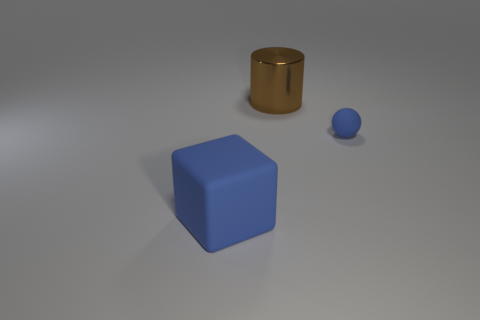Is there any other thing that is the same size as the matte sphere?
Give a very brief answer. No. There is a object that is in front of the small ball; is it the same color as the tiny thing?
Your answer should be very brief. Yes. What is the size of the blue matte object that is on the right side of the big thing that is behind the small blue rubber ball?
Your response must be concise. Small. There is a object that is in front of the metal cylinder and to the left of the tiny ball; what is its color?
Make the answer very short. Blue. There is a cylinder that is the same size as the blue rubber cube; what is its material?
Make the answer very short. Metal. What number of other objects are the same material as the block?
Make the answer very short. 1. There is a thing in front of the small matte object; is its color the same as the rubber thing that is on the right side of the brown cylinder?
Provide a succinct answer. Yes. The large object right of the big thing that is in front of the sphere is what shape?
Your answer should be compact. Cylinder. How many other things are there of the same color as the large metal cylinder?
Give a very brief answer. 0. Is the object in front of the small blue object made of the same material as the thing that is behind the small ball?
Provide a succinct answer. No. 